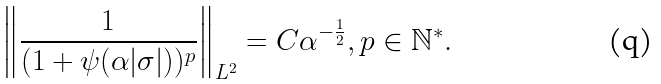Convert formula to latex. <formula><loc_0><loc_0><loc_500><loc_500>\left \| \frac { 1 } { ( 1 + \psi ( \alpha | \sigma | ) ) ^ { p } } \right \| _ { L ^ { 2 } } = C \alpha ^ { - \frac { 1 } { 2 } } , p \in \mathbb { N } ^ { * } .</formula> 